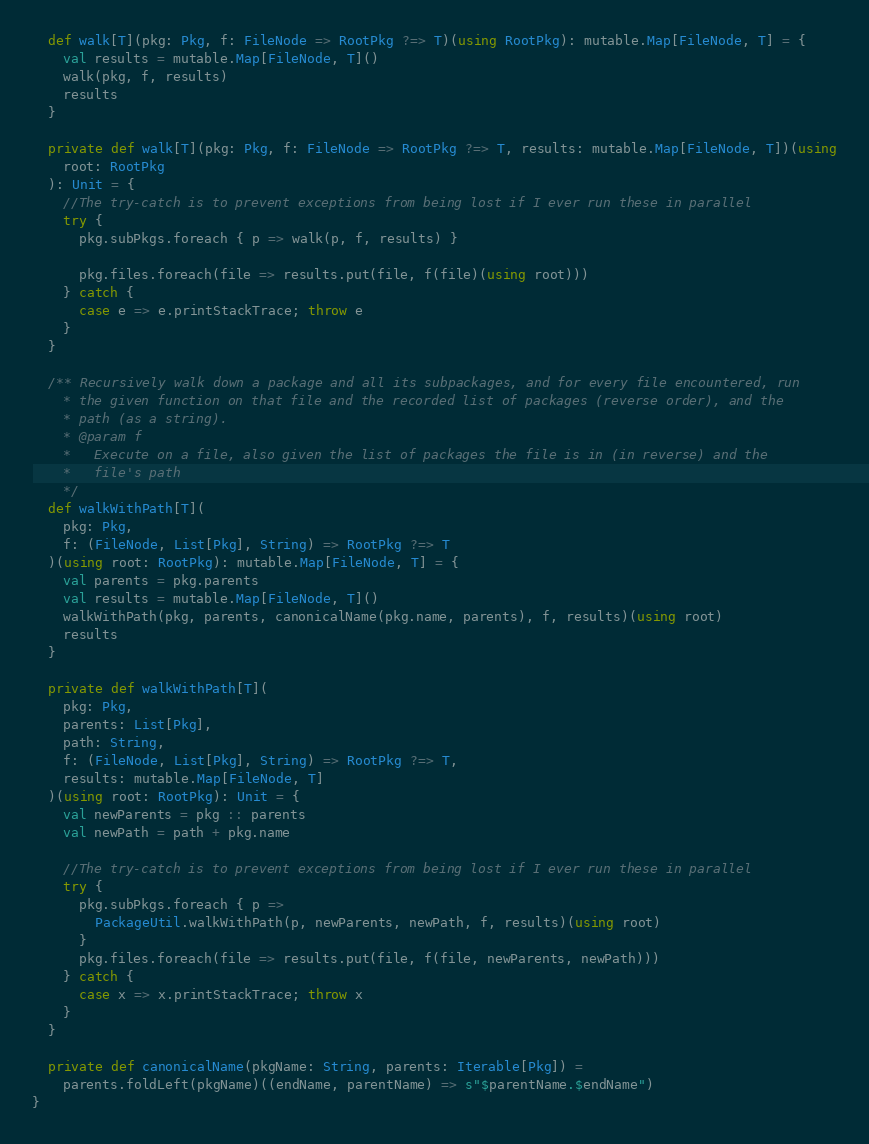<code> <loc_0><loc_0><loc_500><loc_500><_Scala_>  def walk[T](pkg: Pkg, f: FileNode => RootPkg ?=> T)(using RootPkg): mutable.Map[FileNode, T] = {
    val results = mutable.Map[FileNode, T]()
    walk(pkg, f, results)
    results
  }

  private def walk[T](pkg: Pkg, f: FileNode => RootPkg ?=> T, results: mutable.Map[FileNode, T])(using
    root: RootPkg
  ): Unit = {
    //The try-catch is to prevent exceptions from being lost if I ever run these in parallel
    try {
      pkg.subPkgs.foreach { p => walk(p, f, results) }

      pkg.files.foreach(file => results.put(file, f(file)(using root)))
    } catch {
      case e => e.printStackTrace; throw e
    }
  }

  /** Recursively walk down a package and all its subpackages, and for every file encountered, run
    * the given function on that file and the recorded list of packages (reverse order), and the
    * path (as a string).
    * @param f
    *   Execute on a file, also given the list of packages the file is in (in reverse) and the
    *   file's path
    */
  def walkWithPath[T](
    pkg: Pkg,
    f: (FileNode, List[Pkg], String) => RootPkg ?=> T
  )(using root: RootPkg): mutable.Map[FileNode, T] = {
    val parents = pkg.parents
    val results = mutable.Map[FileNode, T]()
    walkWithPath(pkg, parents, canonicalName(pkg.name, parents), f, results)(using root)
    results
  }

  private def walkWithPath[T](
    pkg: Pkg,
    parents: List[Pkg],
    path: String,
    f: (FileNode, List[Pkg], String) => RootPkg ?=> T,
    results: mutable.Map[FileNode, T]
  )(using root: RootPkg): Unit = {
    val newParents = pkg :: parents
    val newPath = path + pkg.name

    //The try-catch is to prevent exceptions from being lost if I ever run these in parallel
    try {
      pkg.subPkgs.foreach { p =>
        PackageUtil.walkWithPath(p, newParents, newPath, f, results)(using root)
      }
      pkg.files.foreach(file => results.put(file, f(file, newParents, newPath)))
    } catch {
      case x => x.printStackTrace; throw x
    }
  }

  private def canonicalName(pkgName: String, parents: Iterable[Pkg]) =
    parents.foldLeft(pkgName)((endName, parentName) => s"$parentName.$endName")
}
</code> 